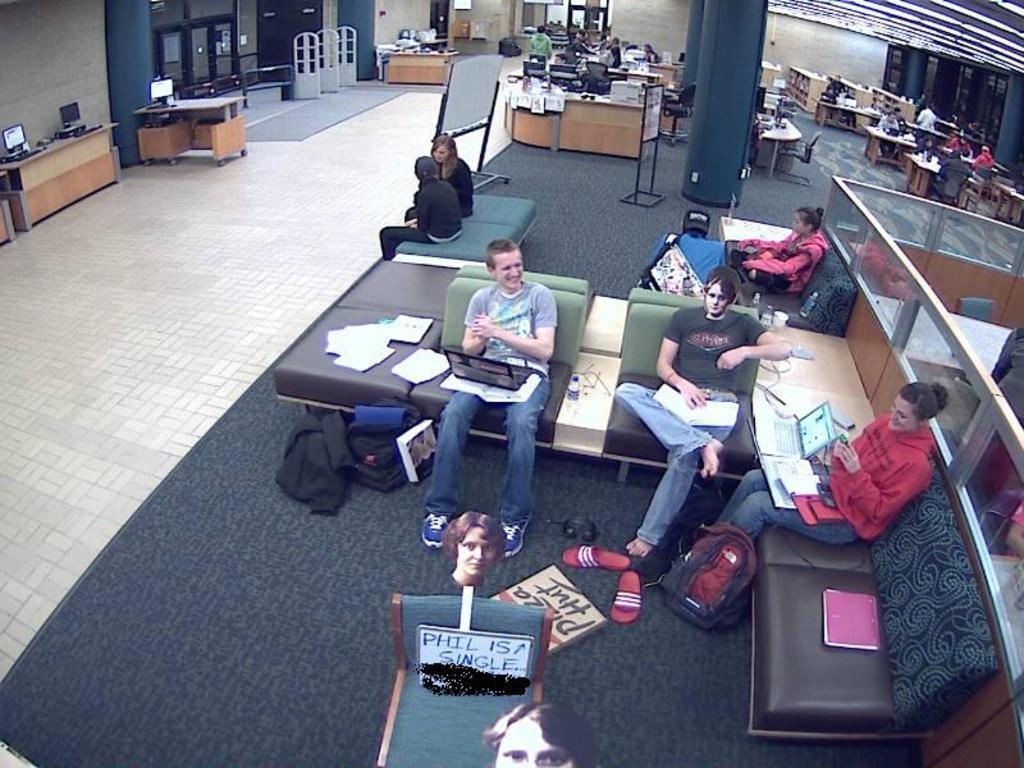Could you give a brief overview of what you see in this image? This is the picture of a hall where we have some chairs, tables and some desk and on the chairs we have some people sitting. 